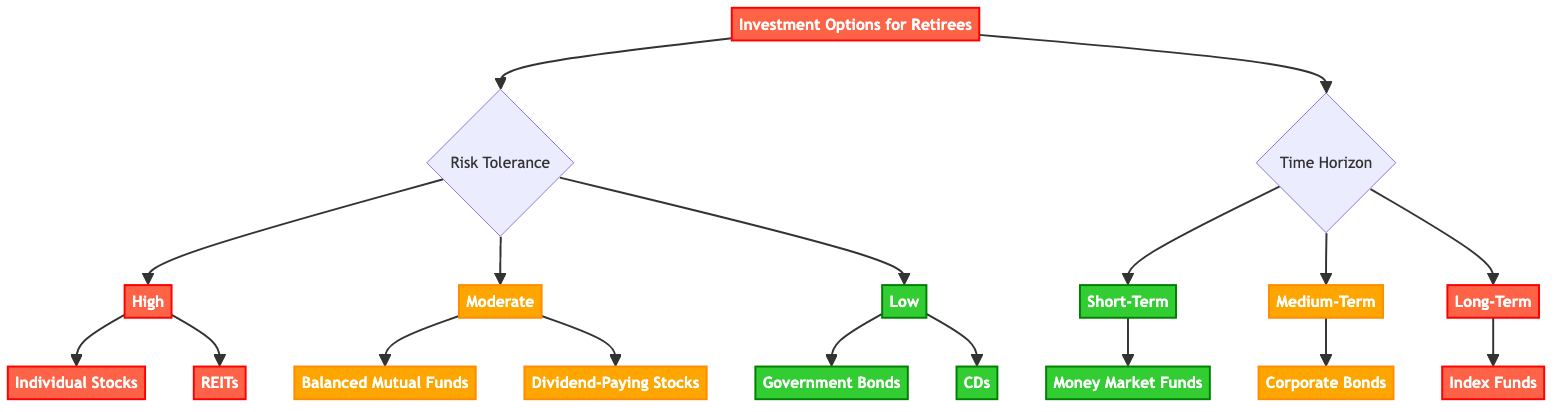What are the three key factors analyzed in the investment options decision guide? The diagram indicates that the key factors analyzed are "Risk Tolerance," "Return Potential," and "Time Horizon."
Answer: Risk Tolerance, Return Potential, Time Horizon How many investment options are listed for high risk tolerance? In the diagram, there are two options listed under the high risk tolerance category: "Individual Stocks" and "Real Estate Investment Trusts (REITs)."
Answer: 2 What investment option is suitable for a low time horizon? The diagram shows that "Money Market Funds" are suitable for a short-term time horizon, indicating low risk.
Answer: Money Market Funds How does the risk tolerance of "Moderate" affect the investment options? The diagram reveals that having a moderate risk tolerance leads to two options: "Balanced Mutual Funds" and "Dividend-Paying Stocks," which balance risk and return.
Answer: Balanced Mutual Funds, Dividend-Paying Stocks What is the return potential of Corporate Bonds? The diagram states that the return potential of Corporate Bonds is "Moderate."
Answer: Moderate Which investment option provides a high return potential with a long-term horizon? Following the logic in the diagram, "Individual Stocks" and "REITs" are highlighted as options that provide high returns over a long-term horizon.
Answer: Individual Stocks, REITs What category links the option "Certificates of Deposit (CDs)"? The option "Certificates of Deposit (CDs)" falls under the "Low" risk tolerance category in the decision tree.
Answer: Low What is the primary focus of this investment options decision guide? According to the diagram, the primary focus is on "Analyzing Investment Options for Retirees."
Answer: Analyzing Investment Options for Retirees 